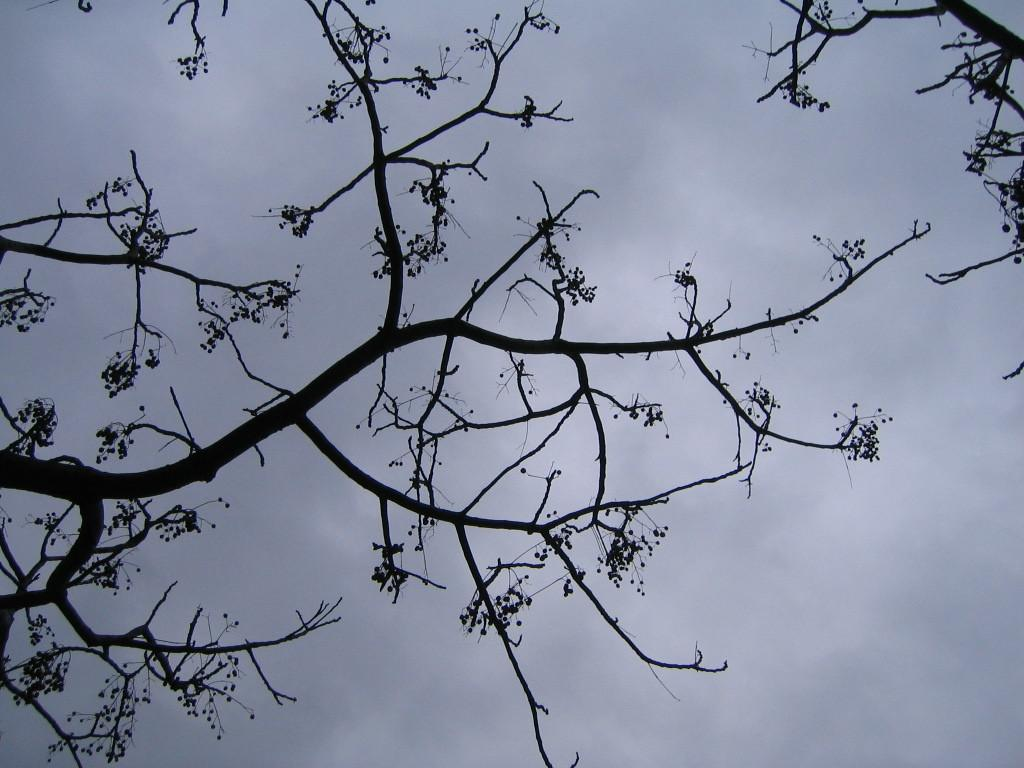What type of vegetation can be seen in the image? There are trees in the image. What part of the natural environment is visible in the image? The sky is visible in the background of the image. How would you describe the weather based on the sky in the image? The sky is cloudy in the image. Can you find any letters written on the leaves of the trees in the image? There are no letters written on the leaves of the trees in the image. Are there any lizards visible on the branches of the trees in the image? There are no lizards visible on the branches of the trees in the image. 